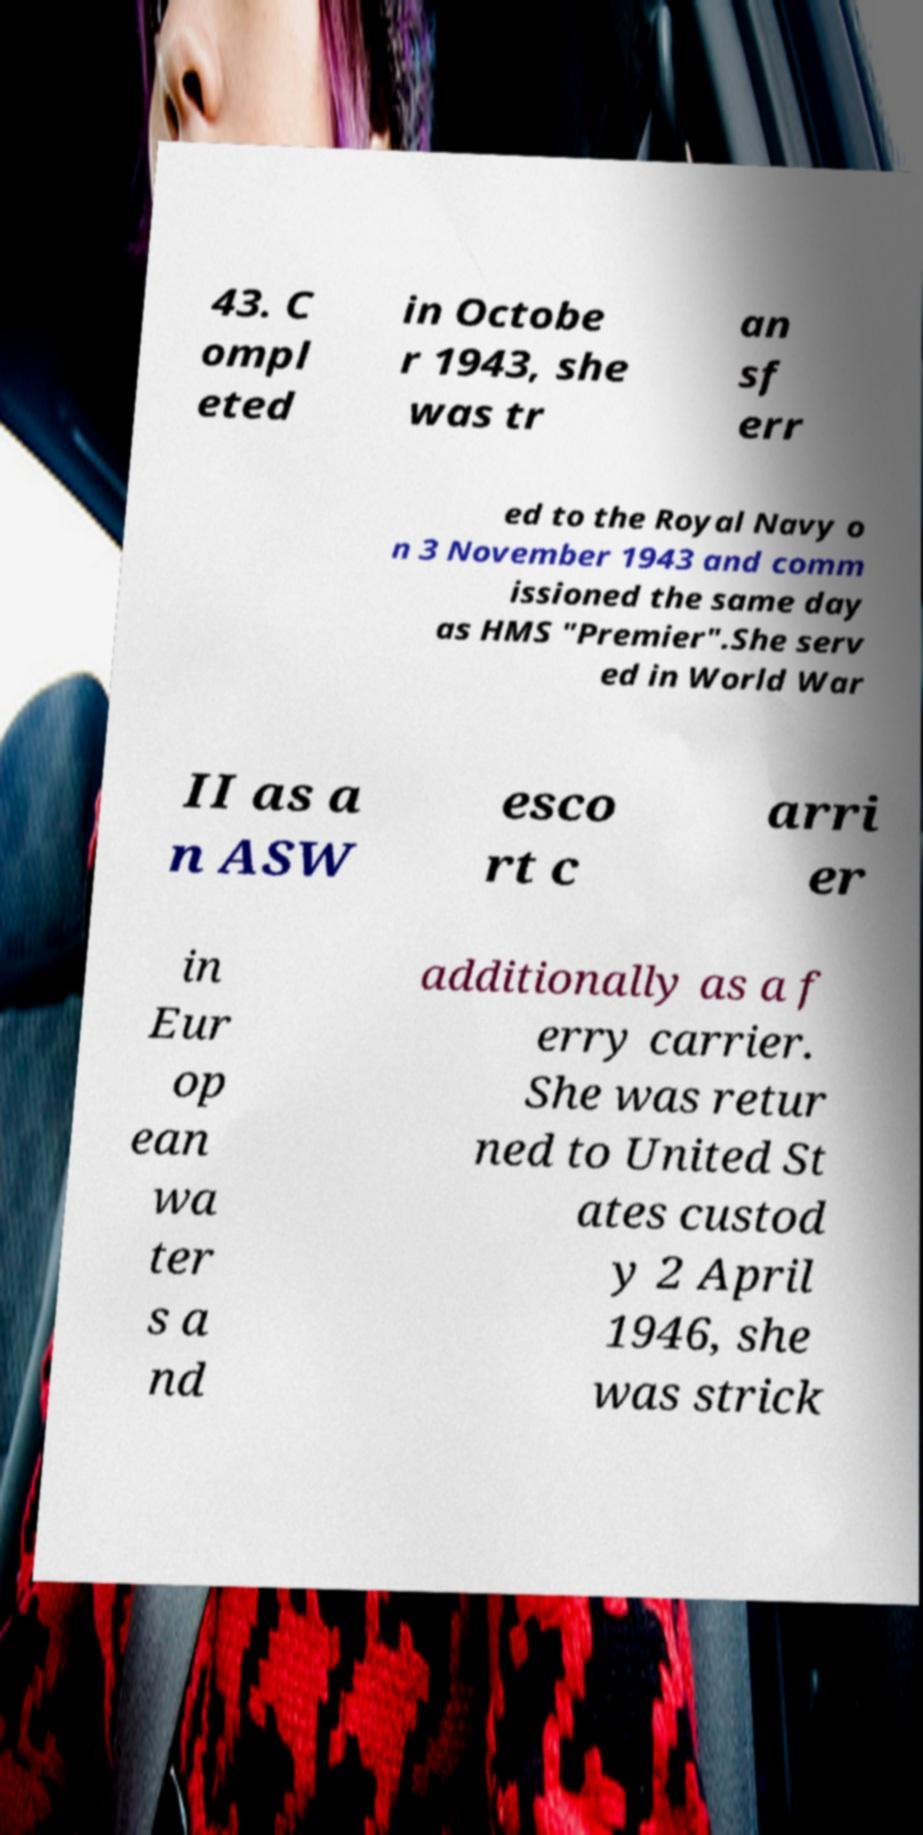Can you read and provide the text displayed in the image?This photo seems to have some interesting text. Can you extract and type it out for me? 43. C ompl eted in Octobe r 1943, she was tr an sf err ed to the Royal Navy o n 3 November 1943 and comm issioned the same day as HMS "Premier".She serv ed in World War II as a n ASW esco rt c arri er in Eur op ean wa ter s a nd additionally as a f erry carrier. She was retur ned to United St ates custod y 2 April 1946, she was strick 